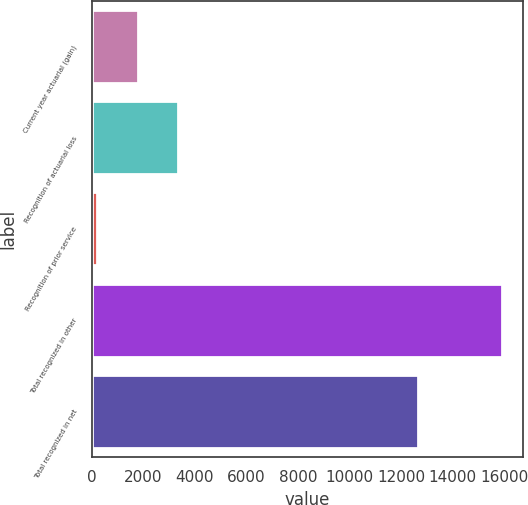Convert chart. <chart><loc_0><loc_0><loc_500><loc_500><bar_chart><fcel>Current year actuarial (gain)<fcel>Recognition of actuarial loss<fcel>Recognition of prior service<fcel>Total recognized in other<fcel>Total recognized in net<nl><fcel>1793.1<fcel>3361.2<fcel>225<fcel>15906<fcel>12665<nl></chart> 